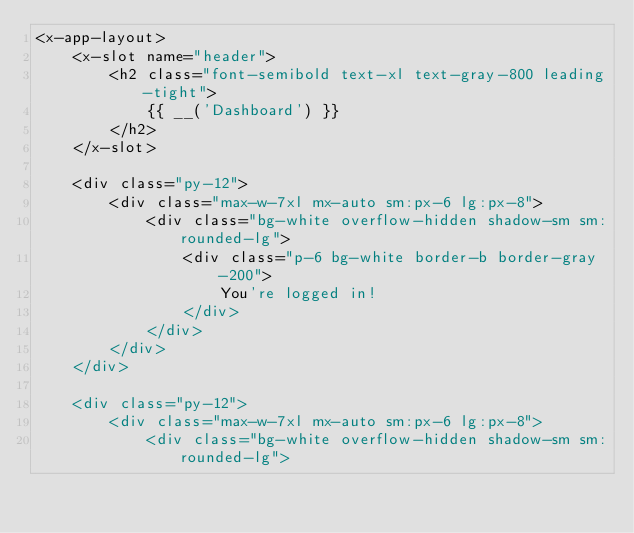<code> <loc_0><loc_0><loc_500><loc_500><_PHP_><x-app-layout>
    <x-slot name="header">
        <h2 class="font-semibold text-xl text-gray-800 leading-tight">
            {{ __('Dashboard') }}
        </h2>
    </x-slot>

    <div class="py-12">
        <div class="max-w-7xl mx-auto sm:px-6 lg:px-8">
            <div class="bg-white overflow-hidden shadow-sm sm:rounded-lg">
                <div class="p-6 bg-white border-b border-gray-200">
                    You're logged in!
                </div>
            </div>
        </div>
    </div>

    <div class="py-12">
        <div class="max-w-7xl mx-auto sm:px-6 lg:px-8">
            <div class="bg-white overflow-hidden shadow-sm sm:rounded-lg"></code> 